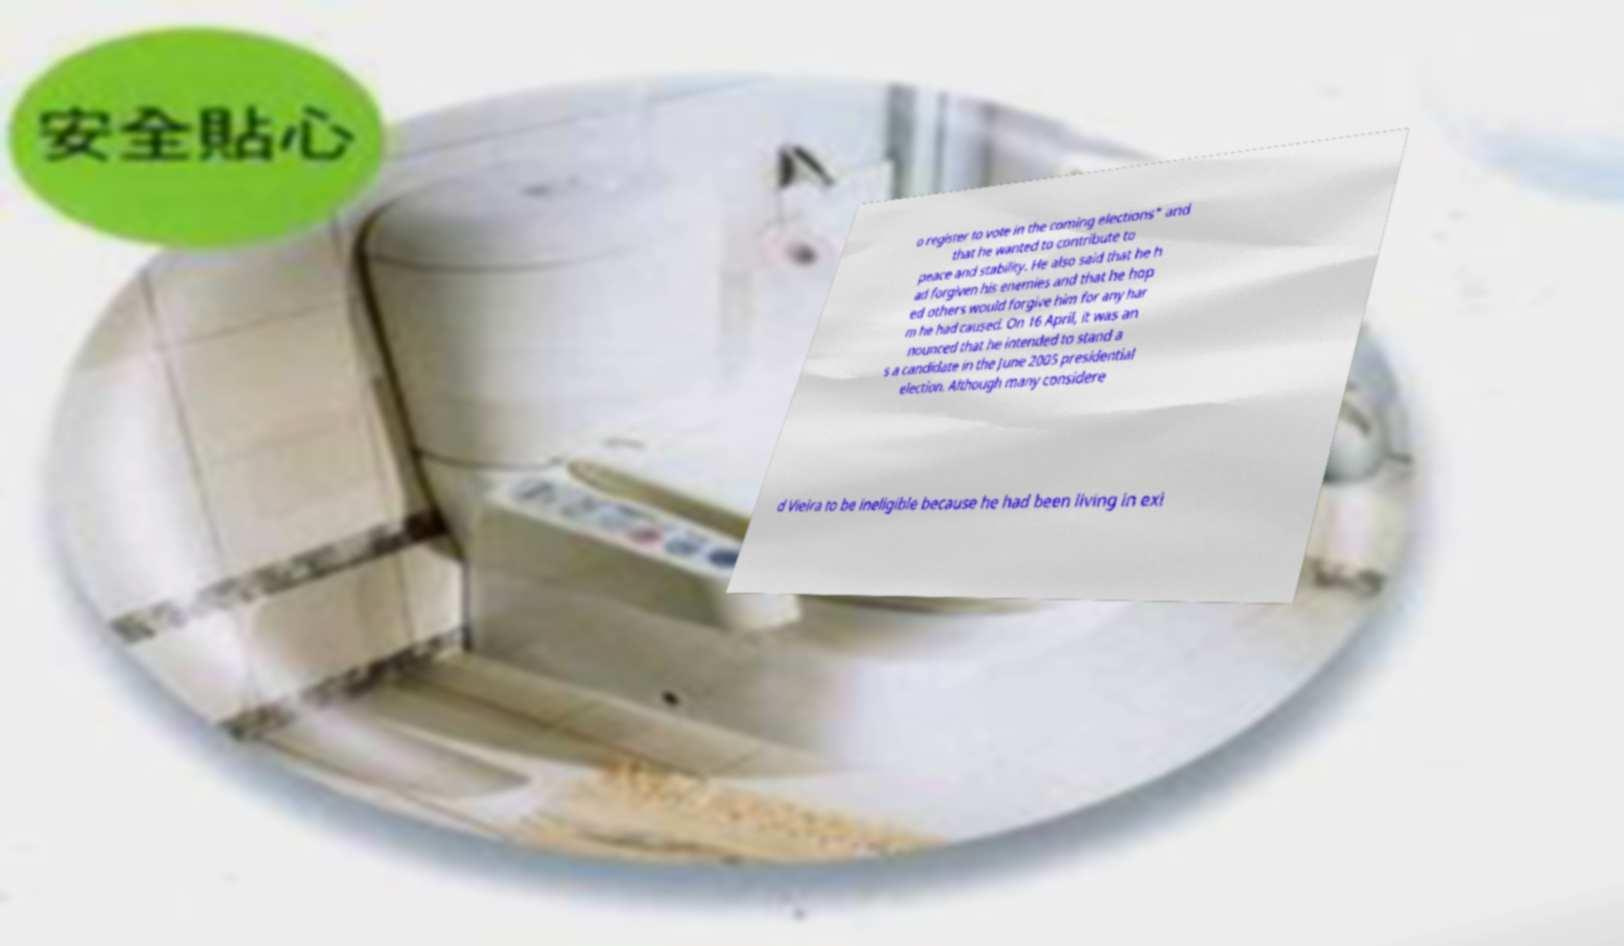Can you read and provide the text displayed in the image?This photo seems to have some interesting text. Can you extract and type it out for me? o register to vote in the coming elections" and that he wanted to contribute to peace and stability. He also said that he h ad forgiven his enemies and that he hop ed others would forgive him for any har m he had caused. On 16 April, it was an nounced that he intended to stand a s a candidate in the June 2005 presidential election. Although many considere d Vieira to be ineligible because he had been living in exi 